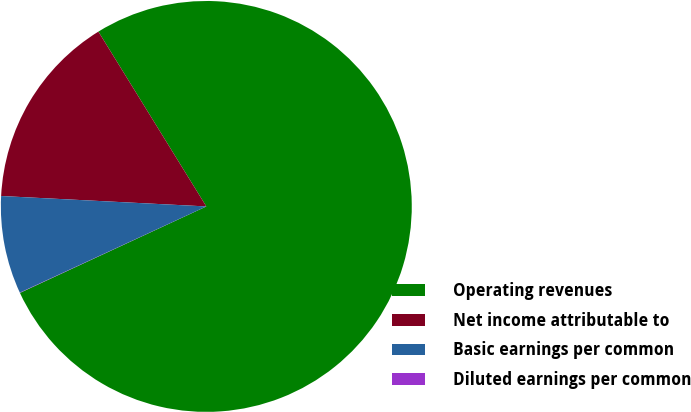Convert chart to OTSL. <chart><loc_0><loc_0><loc_500><loc_500><pie_chart><fcel>Operating revenues<fcel>Net income attributable to<fcel>Basic earnings per common<fcel>Diluted earnings per common<nl><fcel>76.89%<fcel>15.39%<fcel>7.7%<fcel>0.02%<nl></chart> 